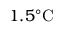<formula> <loc_0><loc_0><loc_500><loc_500>1 . 5 ^ { \circ } C</formula> 